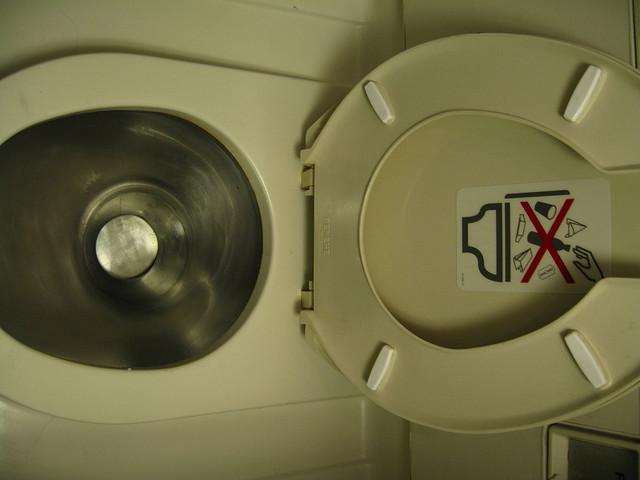Where is this toilet likely located?
Keep it brief. Airplane. What is this object?
Concise answer only. Toilet. Can I throw trash in the toilet?
Be succinct. No. Is there water in the toilet?
Give a very brief answer. No. 